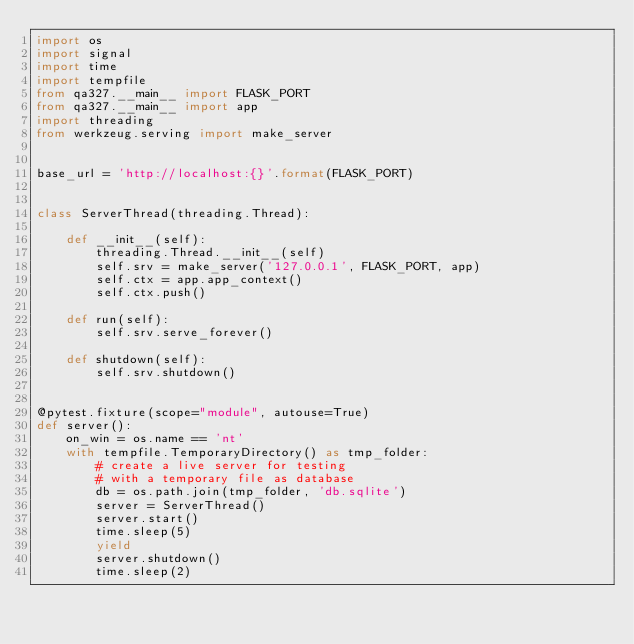Convert code to text. <code><loc_0><loc_0><loc_500><loc_500><_Python_>import os
import signal
import time
import tempfile
from qa327.__main__ import FLASK_PORT
from qa327.__main__ import app
import threading
from werkzeug.serving import make_server


base_url = 'http://localhost:{}'.format(FLASK_PORT)


class ServerThread(threading.Thread):

    def __init__(self):
        threading.Thread.__init__(self)
        self.srv = make_server('127.0.0.1', FLASK_PORT, app)
        self.ctx = app.app_context()
        self.ctx.push()

    def run(self):
        self.srv.serve_forever()

    def shutdown(self):
        self.srv.shutdown()


@pytest.fixture(scope="module", autouse=True)
def server():
    on_win = os.name == 'nt'
    with tempfile.TemporaryDirectory() as tmp_folder:
        # create a live server for testing
        # with a temporary file as database
        db = os.path.join(tmp_folder, 'db.sqlite')
        server = ServerThread()
        server.start()
        time.sleep(5)
        yield
        server.shutdown()
        time.sleep(2)
</code> 